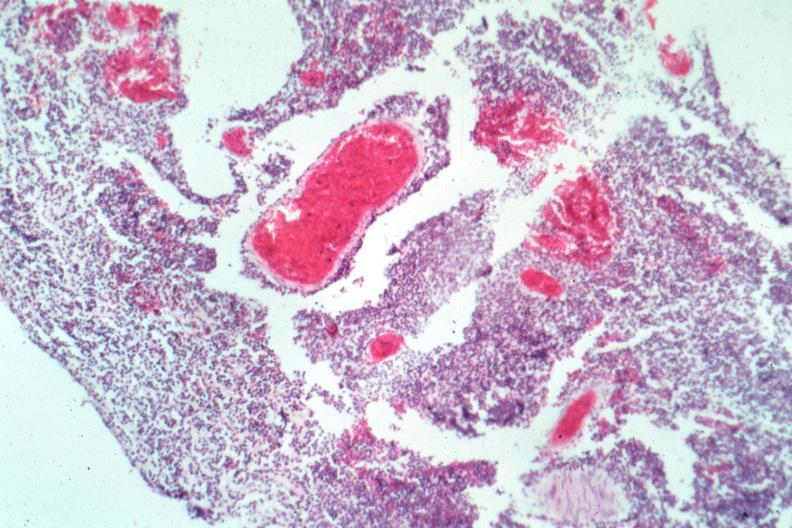does this image show typical not the best micrograph?
Answer the question using a single word or phrase. Yes 